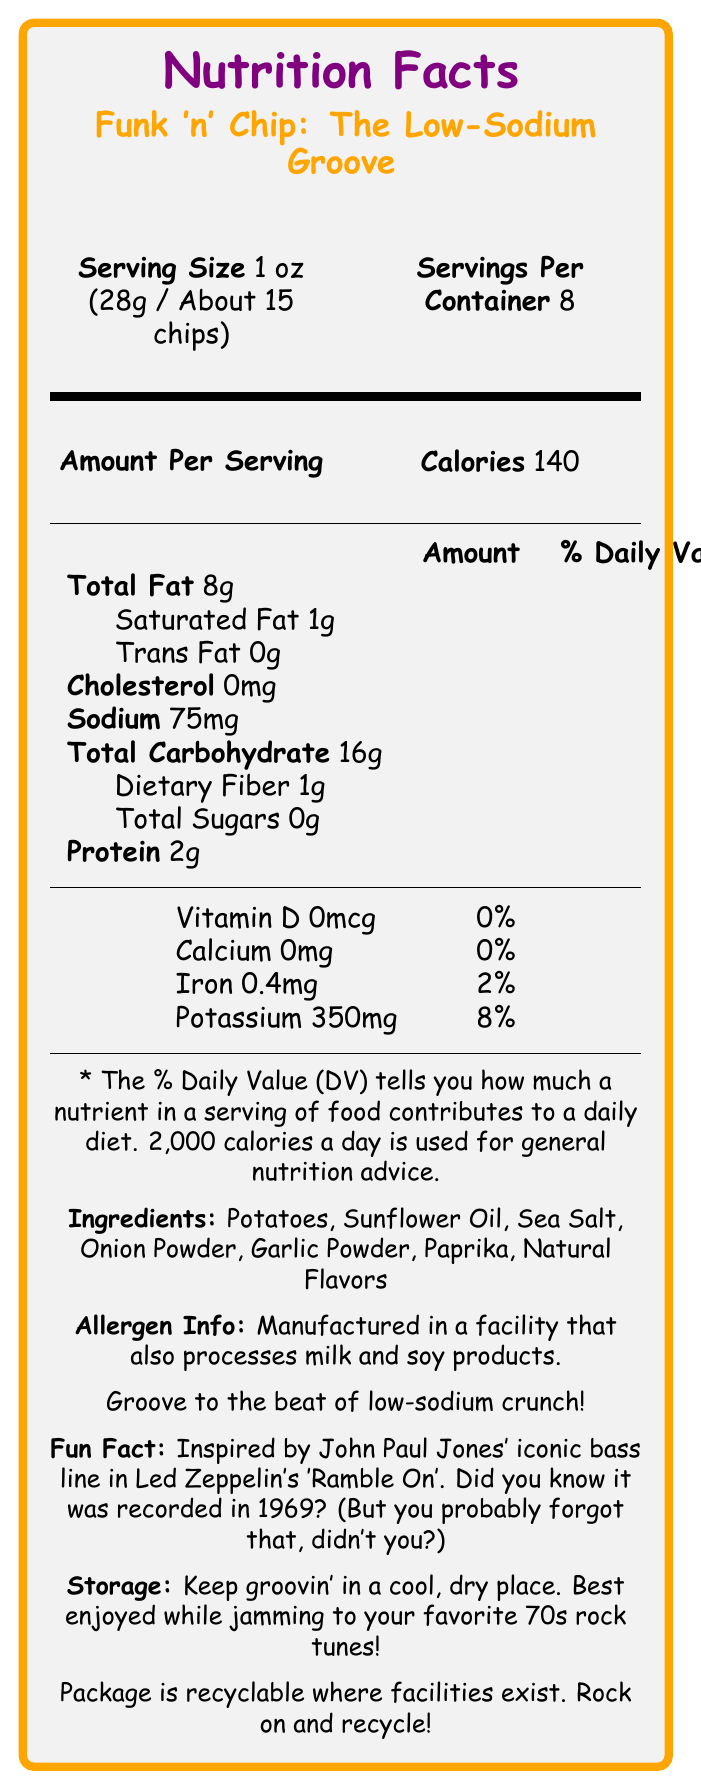what is the serving size? The document specifies that the serving size is 1 oz (28g) or about 15 chips.
Answer: 1 oz (28g / About 15 chips) how many servings are there per container? The document lists that there are 8 servings per container.
Answer: 8 what is the amount of sodium per serving? The document indicates that there are 75mg of sodium per serving.
Answer: 75mg how many calories are in one serving? According to the document, each serving contains 140 calories.
Answer: 140 does the product contain any cholesterol? The document states that the cholesterol amount is 0mg.
Answer: No which nutrient has the highest daily value percentage per serving? A. Sodium B. Total Fat C. Iron D. Potassium The daily value for Total Fat is 10%, which is higher than Sodium (3%), Iron (2%), and Potassium (8%).
Answer: B. Total Fat how much protein is in one serving? The document lists that each serving contains 2g of protein.
Answer: 2g which ingredient is NOT listed in the ingredient list? A. Sea Salt B. Paprika C. Butter D. Garlic Powder The ingredient list includes Sea Salt, Paprika, and Garlic Powder, but not Butter.
Answer: C. Butter is the package recyclable? The document states that the package is recyclable where facilities exist.
Answer: Yes which iconic bass line inspired this product's name? The Fun Fact section reveals that the product is inspired by John Paul Jones' bass line in Led Zeppelin's 'Ramble On'.
Answer: John Paul Jones' bass line in Led Zeppelin's 'Ramble On' how should you store the product for best quality? The storage instructions advise to keep the product in a cool, dry place.
Answer: Keep groovin' in a cool, dry place what percentage of the daily value of iron does one serving provide? The document indicates that one serving provides 2% of the daily value of iron.
Answer: 2% is there any sugar in the product? The document states that the total sugars per serving is 0g.
Answer: No does the product contain dietary fiber? The document lists that each serving includes 1g of dietary fiber.
Answer: Yes what allergen information should consumers be aware of? The allergen information section states that the product is manufactured in a facility that also processes milk and soy products.
Answer: Manufactured in a facility that also processes milk and soy products. describe the main idea of the document. The document provides comprehensive information about the nutritional content, ingredients, and proper storage of the low-sodium potato chip snack "Funk 'n' Chip: The Low-Sodium Groove," and includes a fun fact about its musical inspiration.
Answer: The document is a Nutrition Facts Label for "Funk 'n' Chip: The Low-Sodium Groove," detailing nutritional information, ingredients, allergen info, and storage instructions, with a fun fact about its bass riff inspiration. how many grams of saturated fat does one serving have? The document lists that one serving contains 1g of saturated fat.
Answer: 1g what is the calcium content per serving? The document indicates that the calcium content per serving is 0mg.
Answer: 0mg how many milligrams of potassium are in one serving? The document specifies that each serving contains 350mg of potassium.
Answer: 350mg can you determine which 70s rock tune is best to jam to while enjoying this snack? The document suggests enjoying the snack while jamming to your favorite 70s rock tunes, but does not specify any particular song.
Answer: Cannot be determined 